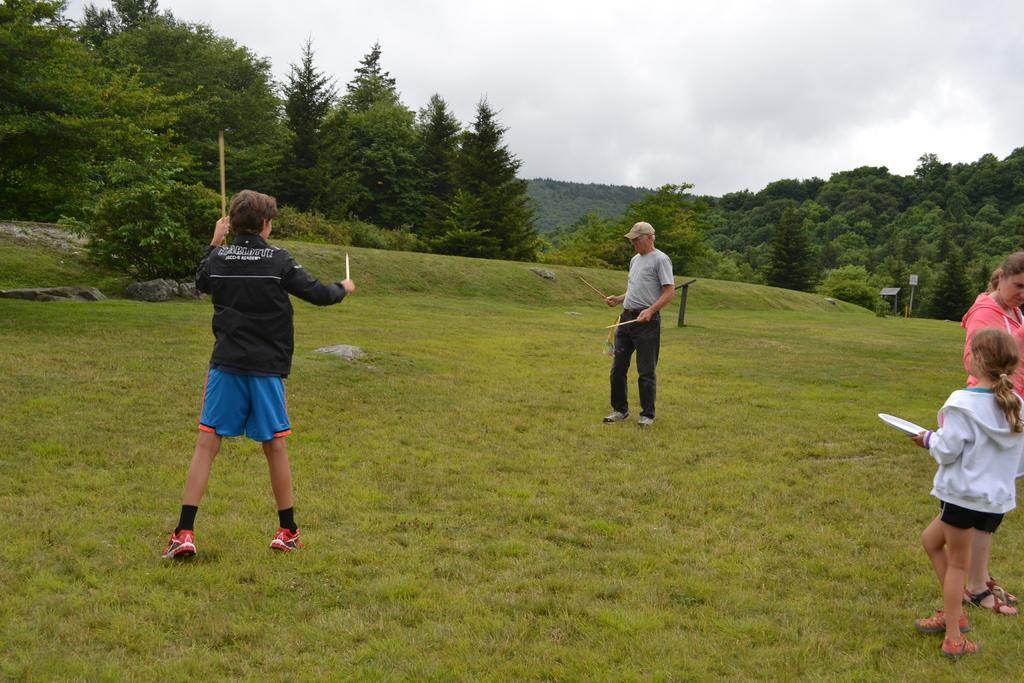In one or two sentences, can you explain what this image depicts? In this image, we can see people and are holding some objects and there is a person wearing a cap and we can see boards. In the background, there are trees and hills. At the top, there is sky and at the bottom, there is ground. 